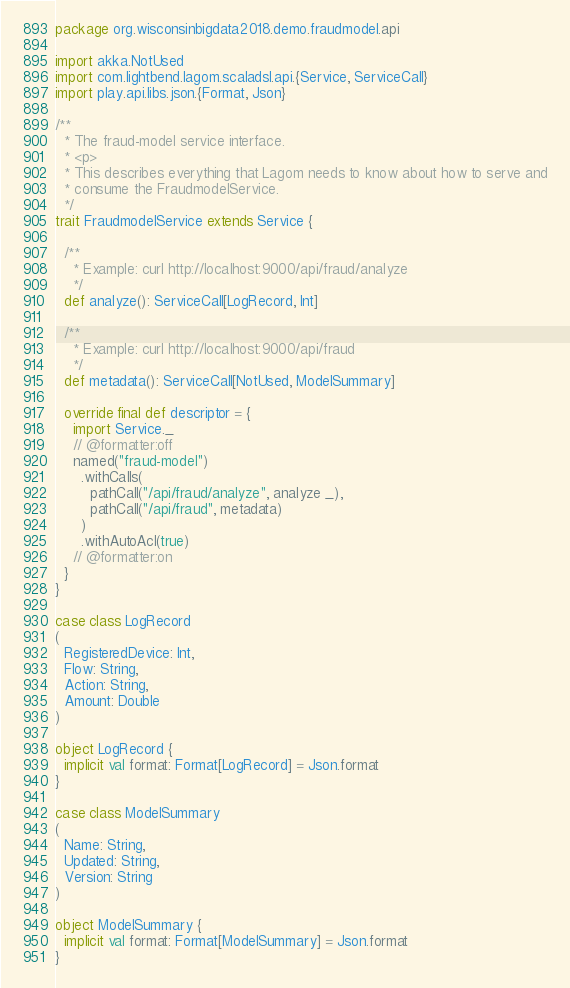Convert code to text. <code><loc_0><loc_0><loc_500><loc_500><_Scala_>package org.wisconsinbigdata2018.demo.fraudmodel.api

import akka.NotUsed
import com.lightbend.lagom.scaladsl.api.{Service, ServiceCall}
import play.api.libs.json.{Format, Json}

/**
  * The fraud-model service interface.
  * <p>
  * This describes everything that Lagom needs to know about how to serve and
  * consume the FraudmodelService.
  */
trait FraudmodelService extends Service {

  /**
    * Example: curl http://localhost:9000/api/fraud/analyze
    */
  def analyze(): ServiceCall[LogRecord, Int]

  /**
    * Example: curl http://localhost:9000/api/fraud
    */
  def metadata(): ServiceCall[NotUsed, ModelSummary]

  override final def descriptor = {
    import Service._
    // @formatter:off
    named("fraud-model")
      .withCalls(
        pathCall("/api/fraud/analyze", analyze _),
        pathCall("/api/fraud", metadata)
      )
      .withAutoAcl(true)
    // @formatter:on
  }
}

case class LogRecord
(
  RegisteredDevice: Int,
  Flow: String,
  Action: String,
  Amount: Double
)

object LogRecord {
  implicit val format: Format[LogRecord] = Json.format
}

case class ModelSummary
(
  Name: String,
  Updated: String,
  Version: String
)

object ModelSummary {
  implicit val format: Format[ModelSummary] = Json.format
}</code> 